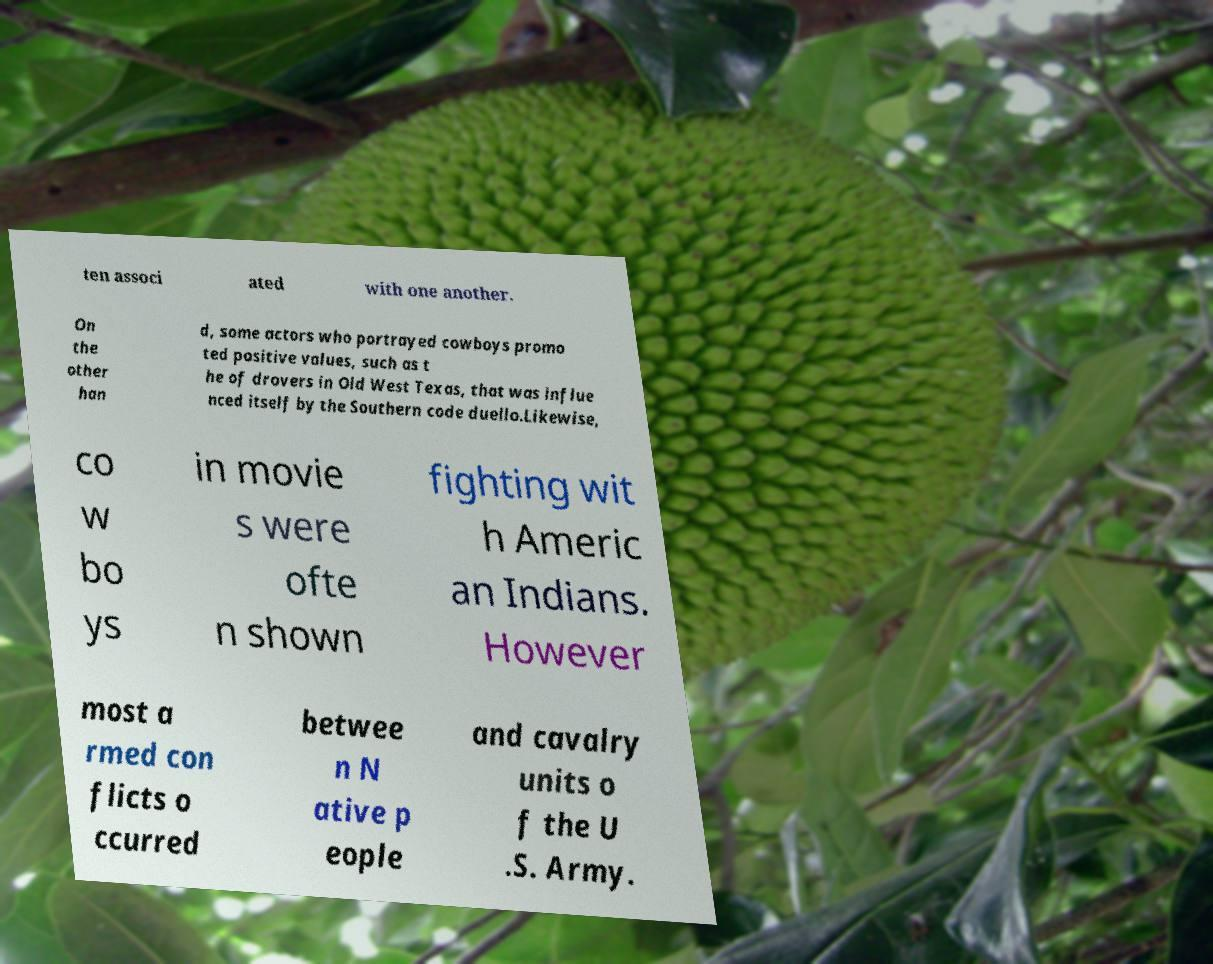Can you read and provide the text displayed in the image?This photo seems to have some interesting text. Can you extract and type it out for me? ten associ ated with one another. On the other han d, some actors who portrayed cowboys promo ted positive values, such as t he of drovers in Old West Texas, that was influe nced itself by the Southern code duello.Likewise, co w bo ys in movie s were ofte n shown fighting wit h Americ an Indians. However most a rmed con flicts o ccurred betwee n N ative p eople and cavalry units o f the U .S. Army. 